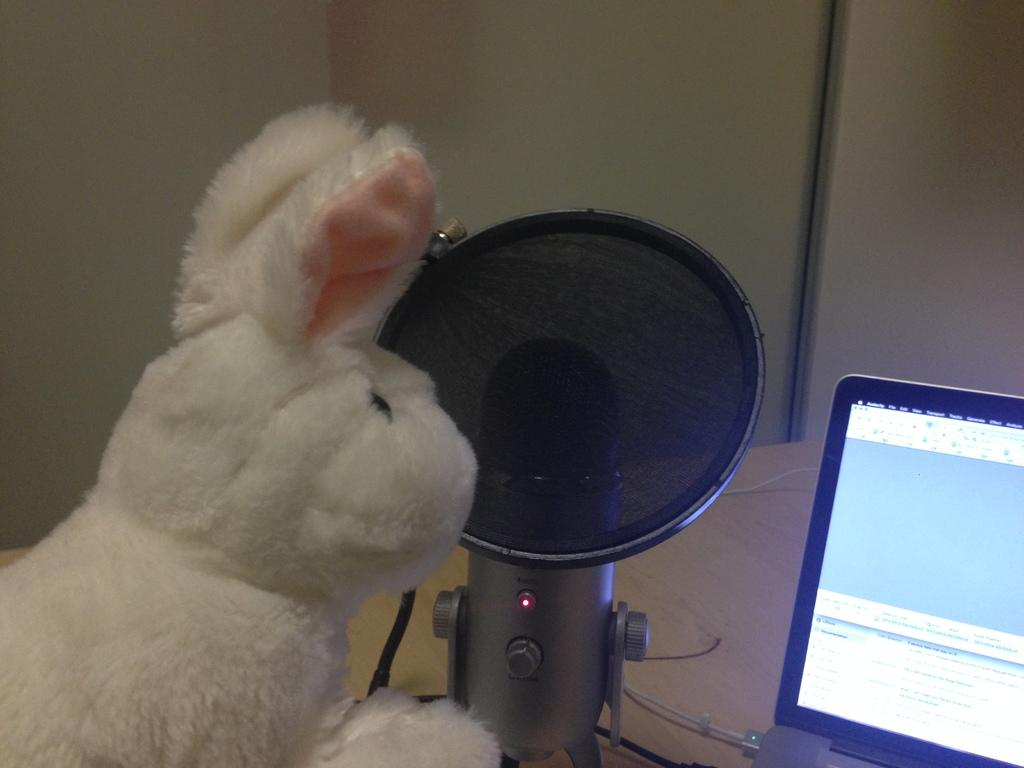What is the main object in the image? There is a doll in the image. What electronic device is visible in the image? There is a laptop in the image. What connects the laptop to other devices or power sources in the image? Cables are present in the image. What device is used for recording or amplifying sound in the image? There is a microphone in the image. What is the object on the table in the image? There is an object on the table in the image, but its specific nature is not mentioned in the facts. What can be seen in the background of the image? There is a wall in the background of the image. What type of crown is the doll wearing in the image? There is no mention of a crown or any other type of headwear in the facts provided. 